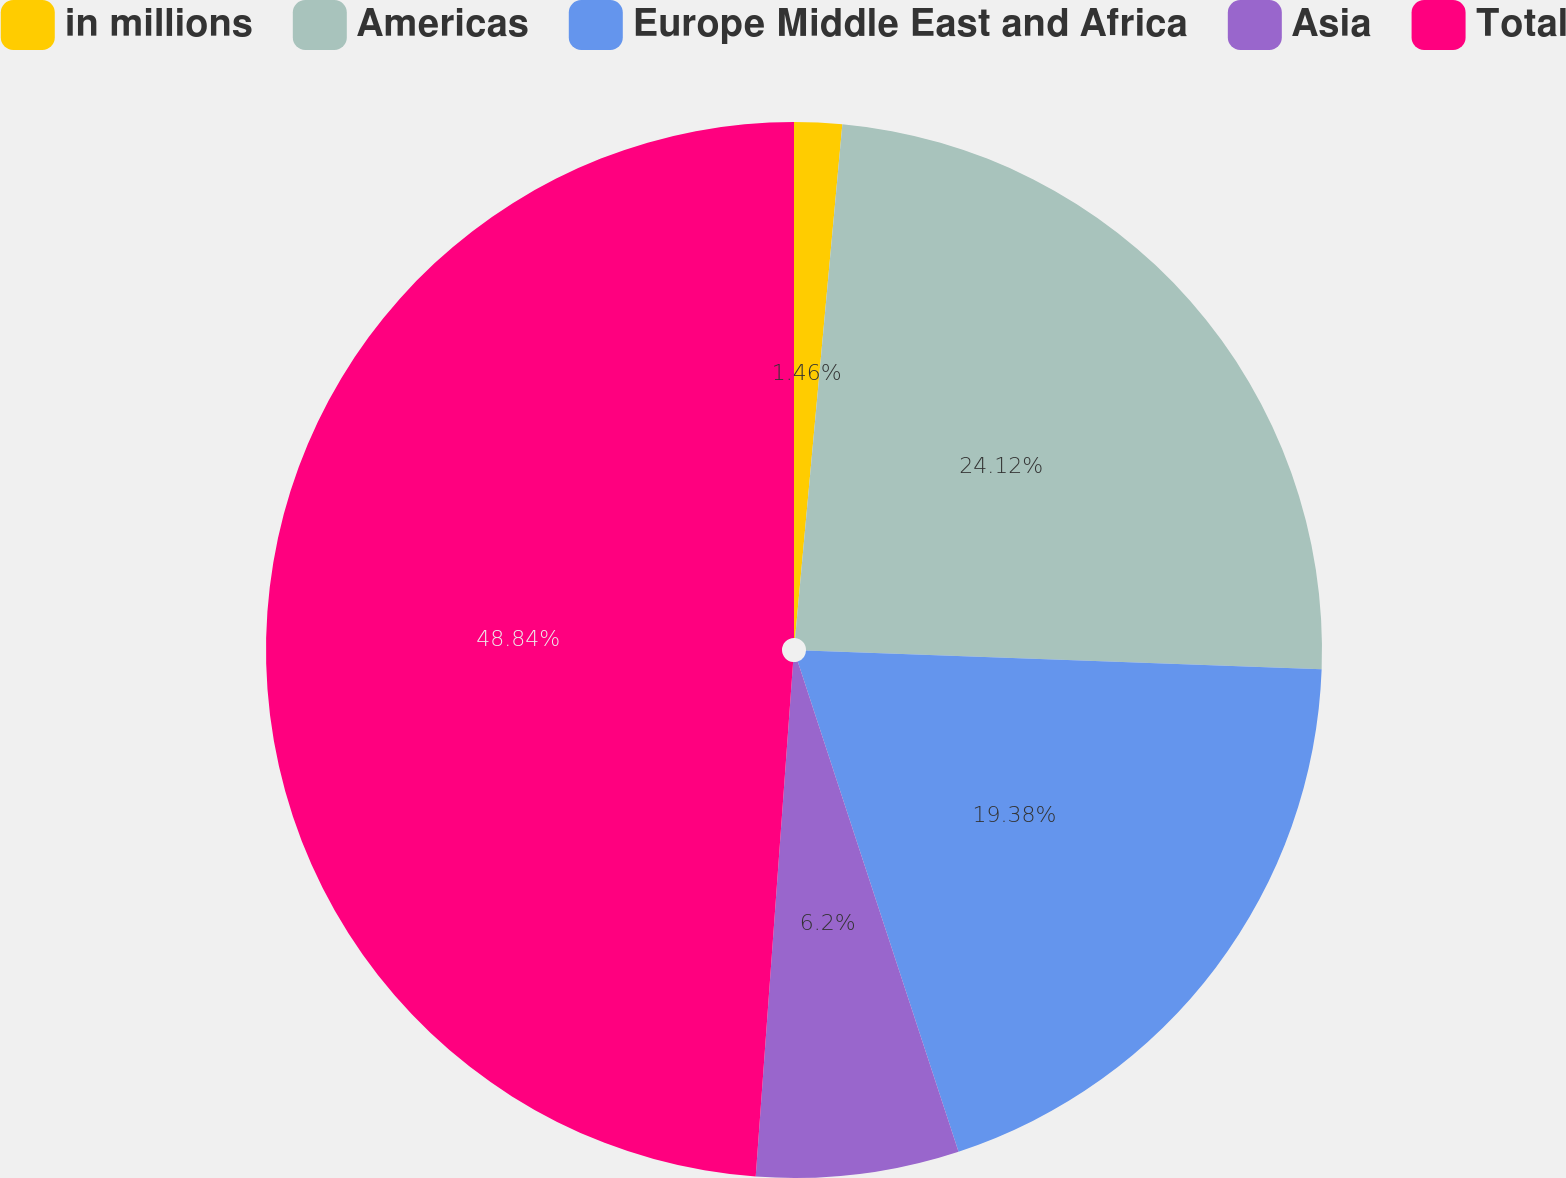Convert chart. <chart><loc_0><loc_0><loc_500><loc_500><pie_chart><fcel>in millions<fcel>Americas<fcel>Europe Middle East and Africa<fcel>Asia<fcel>Total<nl><fcel>1.46%<fcel>24.12%<fcel>19.38%<fcel>6.2%<fcel>48.85%<nl></chart> 